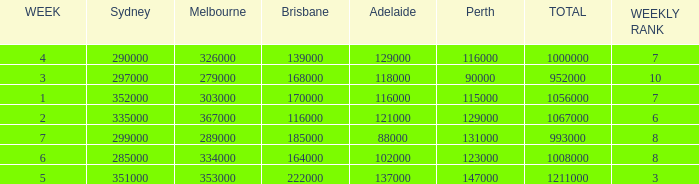How many viewers were there in Sydney for the episode when there were 334000 in Melbourne? 285000.0. 